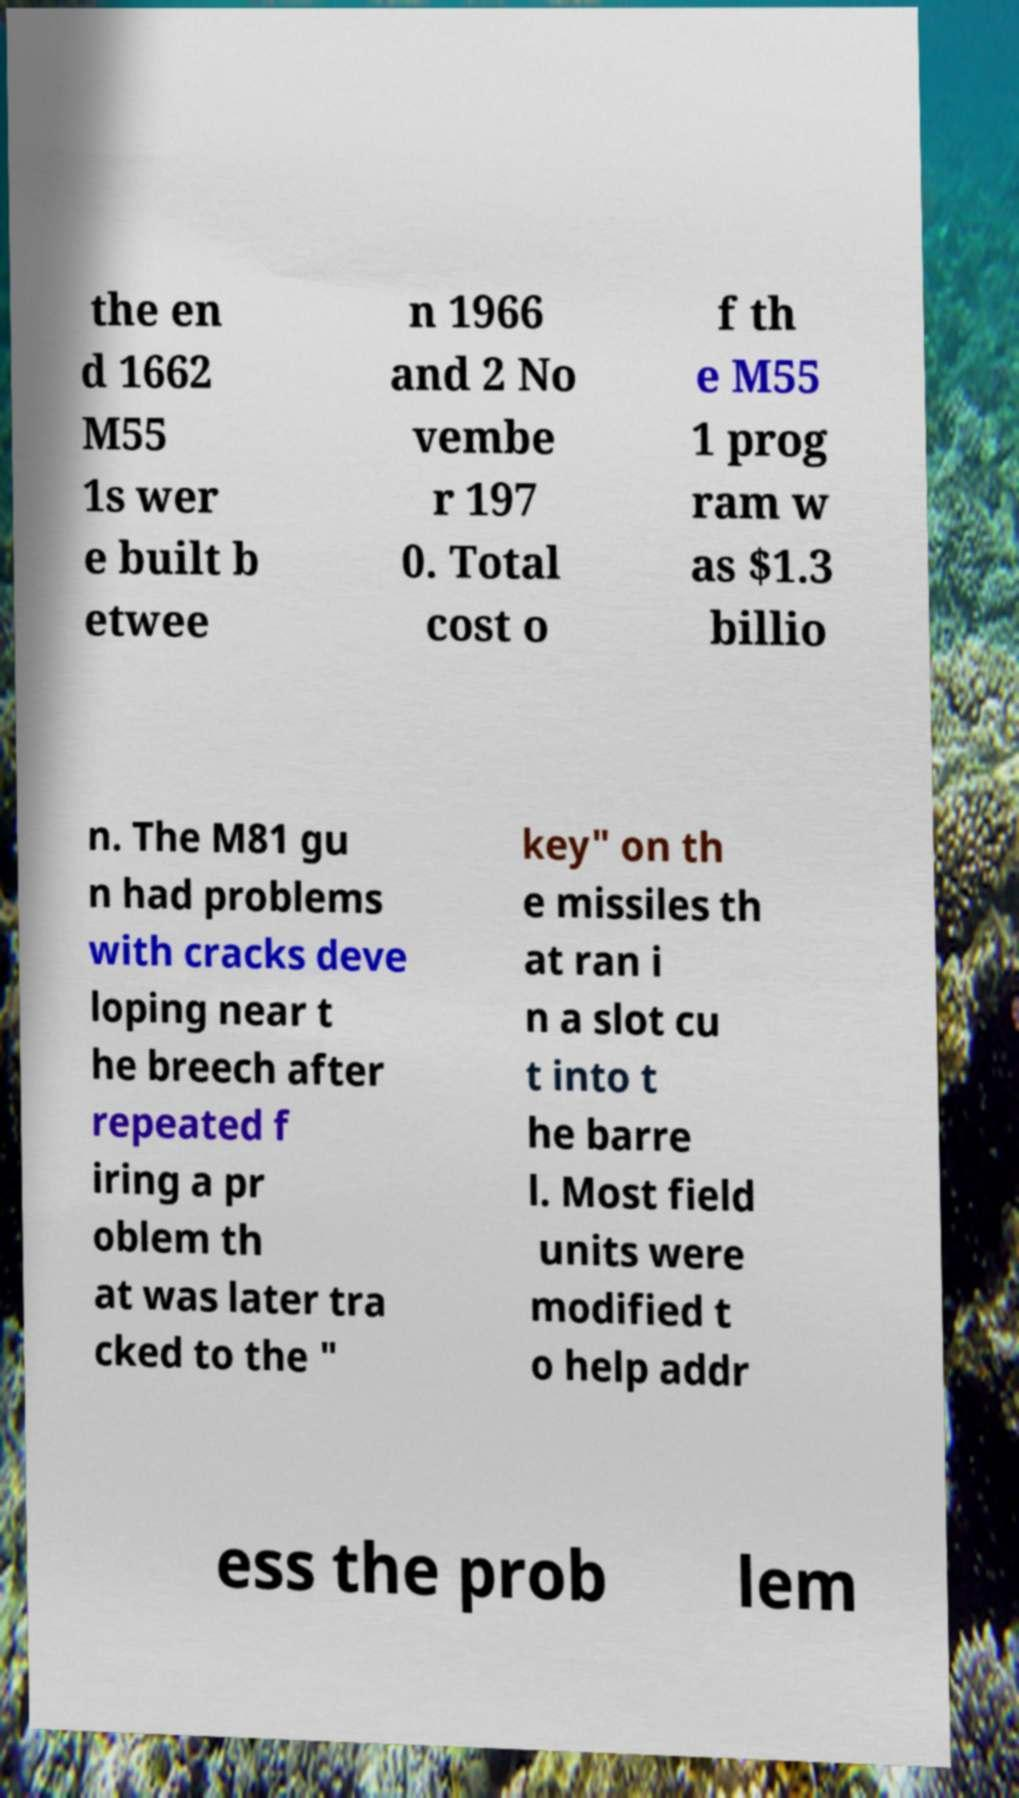I need the written content from this picture converted into text. Can you do that? the en d 1662 M55 1s wer e built b etwee n 1966 and 2 No vembe r 197 0. Total cost o f th e M55 1 prog ram w as $1.3 billio n. The M81 gu n had problems with cracks deve loping near t he breech after repeated f iring a pr oblem th at was later tra cked to the " key" on th e missiles th at ran i n a slot cu t into t he barre l. Most field units were modified t o help addr ess the prob lem 